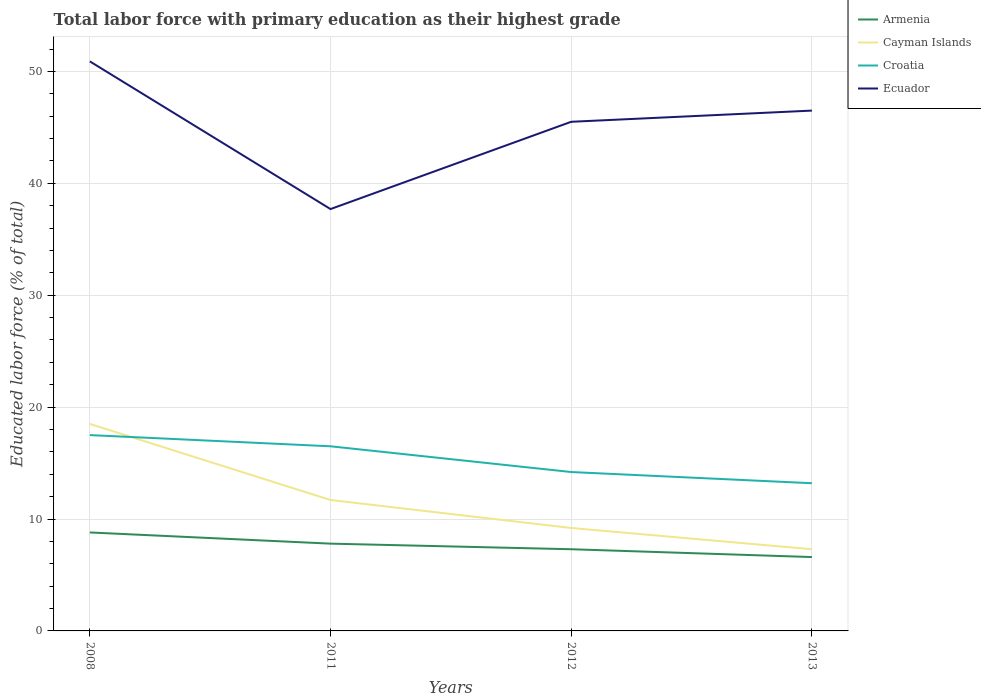Does the line corresponding to Cayman Islands intersect with the line corresponding to Croatia?
Ensure brevity in your answer.  Yes. Across all years, what is the maximum percentage of total labor force with primary education in Cayman Islands?
Offer a very short reply. 7.3. What is the total percentage of total labor force with primary education in Armenia in the graph?
Offer a very short reply. 1. What is the difference between the highest and the second highest percentage of total labor force with primary education in Ecuador?
Keep it short and to the point. 13.2. What is the difference between two consecutive major ticks on the Y-axis?
Keep it short and to the point. 10. Are the values on the major ticks of Y-axis written in scientific E-notation?
Offer a very short reply. No. Does the graph contain any zero values?
Provide a succinct answer. No. Does the graph contain grids?
Your answer should be compact. Yes. Where does the legend appear in the graph?
Provide a short and direct response. Top right. How are the legend labels stacked?
Provide a short and direct response. Vertical. What is the title of the graph?
Make the answer very short. Total labor force with primary education as their highest grade. Does "Bolivia" appear as one of the legend labels in the graph?
Offer a terse response. No. What is the label or title of the X-axis?
Ensure brevity in your answer.  Years. What is the label or title of the Y-axis?
Your answer should be very brief. Educated labor force (% of total). What is the Educated labor force (% of total) in Armenia in 2008?
Give a very brief answer. 8.8. What is the Educated labor force (% of total) in Ecuador in 2008?
Ensure brevity in your answer.  50.9. What is the Educated labor force (% of total) of Armenia in 2011?
Ensure brevity in your answer.  7.8. What is the Educated labor force (% of total) of Cayman Islands in 2011?
Keep it short and to the point. 11.7. What is the Educated labor force (% of total) in Ecuador in 2011?
Keep it short and to the point. 37.7. What is the Educated labor force (% of total) in Armenia in 2012?
Offer a very short reply. 7.3. What is the Educated labor force (% of total) in Cayman Islands in 2012?
Give a very brief answer. 9.2. What is the Educated labor force (% of total) of Croatia in 2012?
Provide a succinct answer. 14.2. What is the Educated labor force (% of total) of Ecuador in 2012?
Your answer should be compact. 45.5. What is the Educated labor force (% of total) in Armenia in 2013?
Make the answer very short. 6.6. What is the Educated labor force (% of total) in Cayman Islands in 2013?
Provide a succinct answer. 7.3. What is the Educated labor force (% of total) in Croatia in 2013?
Ensure brevity in your answer.  13.2. What is the Educated labor force (% of total) of Ecuador in 2013?
Keep it short and to the point. 46.5. Across all years, what is the maximum Educated labor force (% of total) in Armenia?
Provide a succinct answer. 8.8. Across all years, what is the maximum Educated labor force (% of total) in Cayman Islands?
Ensure brevity in your answer.  18.5. Across all years, what is the maximum Educated labor force (% of total) of Croatia?
Offer a terse response. 17.5. Across all years, what is the maximum Educated labor force (% of total) of Ecuador?
Provide a succinct answer. 50.9. Across all years, what is the minimum Educated labor force (% of total) in Armenia?
Offer a terse response. 6.6. Across all years, what is the minimum Educated labor force (% of total) of Cayman Islands?
Your response must be concise. 7.3. Across all years, what is the minimum Educated labor force (% of total) of Croatia?
Keep it short and to the point. 13.2. Across all years, what is the minimum Educated labor force (% of total) in Ecuador?
Provide a short and direct response. 37.7. What is the total Educated labor force (% of total) of Armenia in the graph?
Your answer should be compact. 30.5. What is the total Educated labor force (% of total) in Cayman Islands in the graph?
Give a very brief answer. 46.7. What is the total Educated labor force (% of total) in Croatia in the graph?
Give a very brief answer. 61.4. What is the total Educated labor force (% of total) in Ecuador in the graph?
Your response must be concise. 180.6. What is the difference between the Educated labor force (% of total) in Armenia in 2008 and that in 2011?
Keep it short and to the point. 1. What is the difference between the Educated labor force (% of total) in Croatia in 2008 and that in 2011?
Provide a short and direct response. 1. What is the difference between the Educated labor force (% of total) of Croatia in 2008 and that in 2012?
Your response must be concise. 3.3. What is the difference between the Educated labor force (% of total) in Armenia in 2008 and that in 2013?
Keep it short and to the point. 2.2. What is the difference between the Educated labor force (% of total) in Croatia in 2008 and that in 2013?
Your response must be concise. 4.3. What is the difference between the Educated labor force (% of total) of Armenia in 2011 and that in 2012?
Your answer should be compact. 0.5. What is the difference between the Educated labor force (% of total) of Ecuador in 2011 and that in 2012?
Give a very brief answer. -7.8. What is the difference between the Educated labor force (% of total) of Cayman Islands in 2011 and that in 2013?
Your response must be concise. 4.4. What is the difference between the Educated labor force (% of total) in Armenia in 2012 and that in 2013?
Provide a short and direct response. 0.7. What is the difference between the Educated labor force (% of total) of Croatia in 2012 and that in 2013?
Provide a short and direct response. 1. What is the difference between the Educated labor force (% of total) in Ecuador in 2012 and that in 2013?
Your response must be concise. -1. What is the difference between the Educated labor force (% of total) of Armenia in 2008 and the Educated labor force (% of total) of Ecuador in 2011?
Provide a succinct answer. -28.9. What is the difference between the Educated labor force (% of total) of Cayman Islands in 2008 and the Educated labor force (% of total) of Croatia in 2011?
Provide a succinct answer. 2. What is the difference between the Educated labor force (% of total) of Cayman Islands in 2008 and the Educated labor force (% of total) of Ecuador in 2011?
Provide a short and direct response. -19.2. What is the difference between the Educated labor force (% of total) in Croatia in 2008 and the Educated labor force (% of total) in Ecuador in 2011?
Your response must be concise. -20.2. What is the difference between the Educated labor force (% of total) of Armenia in 2008 and the Educated labor force (% of total) of Cayman Islands in 2012?
Provide a short and direct response. -0.4. What is the difference between the Educated labor force (% of total) of Armenia in 2008 and the Educated labor force (% of total) of Croatia in 2012?
Give a very brief answer. -5.4. What is the difference between the Educated labor force (% of total) in Armenia in 2008 and the Educated labor force (% of total) in Ecuador in 2012?
Your response must be concise. -36.7. What is the difference between the Educated labor force (% of total) of Cayman Islands in 2008 and the Educated labor force (% of total) of Croatia in 2012?
Your response must be concise. 4.3. What is the difference between the Educated labor force (% of total) of Cayman Islands in 2008 and the Educated labor force (% of total) of Ecuador in 2012?
Give a very brief answer. -27. What is the difference between the Educated labor force (% of total) in Croatia in 2008 and the Educated labor force (% of total) in Ecuador in 2012?
Offer a terse response. -28. What is the difference between the Educated labor force (% of total) of Armenia in 2008 and the Educated labor force (% of total) of Croatia in 2013?
Offer a terse response. -4.4. What is the difference between the Educated labor force (% of total) of Armenia in 2008 and the Educated labor force (% of total) of Ecuador in 2013?
Provide a succinct answer. -37.7. What is the difference between the Educated labor force (% of total) of Cayman Islands in 2008 and the Educated labor force (% of total) of Croatia in 2013?
Give a very brief answer. 5.3. What is the difference between the Educated labor force (% of total) in Croatia in 2008 and the Educated labor force (% of total) in Ecuador in 2013?
Offer a very short reply. -29. What is the difference between the Educated labor force (% of total) of Armenia in 2011 and the Educated labor force (% of total) of Cayman Islands in 2012?
Offer a terse response. -1.4. What is the difference between the Educated labor force (% of total) in Armenia in 2011 and the Educated labor force (% of total) in Croatia in 2012?
Keep it short and to the point. -6.4. What is the difference between the Educated labor force (% of total) of Armenia in 2011 and the Educated labor force (% of total) of Ecuador in 2012?
Provide a succinct answer. -37.7. What is the difference between the Educated labor force (% of total) in Cayman Islands in 2011 and the Educated labor force (% of total) in Croatia in 2012?
Give a very brief answer. -2.5. What is the difference between the Educated labor force (% of total) in Cayman Islands in 2011 and the Educated labor force (% of total) in Ecuador in 2012?
Ensure brevity in your answer.  -33.8. What is the difference between the Educated labor force (% of total) in Armenia in 2011 and the Educated labor force (% of total) in Ecuador in 2013?
Your answer should be compact. -38.7. What is the difference between the Educated labor force (% of total) in Cayman Islands in 2011 and the Educated labor force (% of total) in Croatia in 2013?
Offer a terse response. -1.5. What is the difference between the Educated labor force (% of total) of Cayman Islands in 2011 and the Educated labor force (% of total) of Ecuador in 2013?
Your answer should be compact. -34.8. What is the difference between the Educated labor force (% of total) in Croatia in 2011 and the Educated labor force (% of total) in Ecuador in 2013?
Provide a succinct answer. -30. What is the difference between the Educated labor force (% of total) of Armenia in 2012 and the Educated labor force (% of total) of Ecuador in 2013?
Offer a very short reply. -39.2. What is the difference between the Educated labor force (% of total) in Cayman Islands in 2012 and the Educated labor force (% of total) in Ecuador in 2013?
Your answer should be very brief. -37.3. What is the difference between the Educated labor force (% of total) in Croatia in 2012 and the Educated labor force (% of total) in Ecuador in 2013?
Provide a succinct answer. -32.3. What is the average Educated labor force (% of total) in Armenia per year?
Keep it short and to the point. 7.62. What is the average Educated labor force (% of total) in Cayman Islands per year?
Make the answer very short. 11.68. What is the average Educated labor force (% of total) in Croatia per year?
Your response must be concise. 15.35. What is the average Educated labor force (% of total) in Ecuador per year?
Offer a terse response. 45.15. In the year 2008, what is the difference between the Educated labor force (% of total) in Armenia and Educated labor force (% of total) in Cayman Islands?
Offer a very short reply. -9.7. In the year 2008, what is the difference between the Educated labor force (% of total) of Armenia and Educated labor force (% of total) of Croatia?
Make the answer very short. -8.7. In the year 2008, what is the difference between the Educated labor force (% of total) of Armenia and Educated labor force (% of total) of Ecuador?
Ensure brevity in your answer.  -42.1. In the year 2008, what is the difference between the Educated labor force (% of total) of Cayman Islands and Educated labor force (% of total) of Croatia?
Make the answer very short. 1. In the year 2008, what is the difference between the Educated labor force (% of total) of Cayman Islands and Educated labor force (% of total) of Ecuador?
Your answer should be compact. -32.4. In the year 2008, what is the difference between the Educated labor force (% of total) in Croatia and Educated labor force (% of total) in Ecuador?
Your response must be concise. -33.4. In the year 2011, what is the difference between the Educated labor force (% of total) in Armenia and Educated labor force (% of total) in Cayman Islands?
Ensure brevity in your answer.  -3.9. In the year 2011, what is the difference between the Educated labor force (% of total) of Armenia and Educated labor force (% of total) of Croatia?
Offer a very short reply. -8.7. In the year 2011, what is the difference between the Educated labor force (% of total) of Armenia and Educated labor force (% of total) of Ecuador?
Make the answer very short. -29.9. In the year 2011, what is the difference between the Educated labor force (% of total) of Cayman Islands and Educated labor force (% of total) of Croatia?
Provide a succinct answer. -4.8. In the year 2011, what is the difference between the Educated labor force (% of total) in Croatia and Educated labor force (% of total) in Ecuador?
Offer a terse response. -21.2. In the year 2012, what is the difference between the Educated labor force (% of total) in Armenia and Educated labor force (% of total) in Ecuador?
Keep it short and to the point. -38.2. In the year 2012, what is the difference between the Educated labor force (% of total) of Cayman Islands and Educated labor force (% of total) of Croatia?
Ensure brevity in your answer.  -5. In the year 2012, what is the difference between the Educated labor force (% of total) in Cayman Islands and Educated labor force (% of total) in Ecuador?
Offer a terse response. -36.3. In the year 2012, what is the difference between the Educated labor force (% of total) of Croatia and Educated labor force (% of total) of Ecuador?
Your answer should be very brief. -31.3. In the year 2013, what is the difference between the Educated labor force (% of total) in Armenia and Educated labor force (% of total) in Cayman Islands?
Give a very brief answer. -0.7. In the year 2013, what is the difference between the Educated labor force (% of total) in Armenia and Educated labor force (% of total) in Ecuador?
Keep it short and to the point. -39.9. In the year 2013, what is the difference between the Educated labor force (% of total) in Cayman Islands and Educated labor force (% of total) in Croatia?
Your answer should be compact. -5.9. In the year 2013, what is the difference between the Educated labor force (% of total) of Cayman Islands and Educated labor force (% of total) of Ecuador?
Your answer should be compact. -39.2. In the year 2013, what is the difference between the Educated labor force (% of total) in Croatia and Educated labor force (% of total) in Ecuador?
Your answer should be compact. -33.3. What is the ratio of the Educated labor force (% of total) of Armenia in 2008 to that in 2011?
Ensure brevity in your answer.  1.13. What is the ratio of the Educated labor force (% of total) in Cayman Islands in 2008 to that in 2011?
Offer a very short reply. 1.58. What is the ratio of the Educated labor force (% of total) in Croatia in 2008 to that in 2011?
Keep it short and to the point. 1.06. What is the ratio of the Educated labor force (% of total) in Ecuador in 2008 to that in 2011?
Make the answer very short. 1.35. What is the ratio of the Educated labor force (% of total) of Armenia in 2008 to that in 2012?
Your response must be concise. 1.21. What is the ratio of the Educated labor force (% of total) of Cayman Islands in 2008 to that in 2012?
Your answer should be very brief. 2.01. What is the ratio of the Educated labor force (% of total) in Croatia in 2008 to that in 2012?
Provide a short and direct response. 1.23. What is the ratio of the Educated labor force (% of total) of Ecuador in 2008 to that in 2012?
Ensure brevity in your answer.  1.12. What is the ratio of the Educated labor force (% of total) in Armenia in 2008 to that in 2013?
Provide a short and direct response. 1.33. What is the ratio of the Educated labor force (% of total) in Cayman Islands in 2008 to that in 2013?
Make the answer very short. 2.53. What is the ratio of the Educated labor force (% of total) of Croatia in 2008 to that in 2013?
Provide a succinct answer. 1.33. What is the ratio of the Educated labor force (% of total) in Ecuador in 2008 to that in 2013?
Give a very brief answer. 1.09. What is the ratio of the Educated labor force (% of total) in Armenia in 2011 to that in 2012?
Provide a short and direct response. 1.07. What is the ratio of the Educated labor force (% of total) of Cayman Islands in 2011 to that in 2012?
Your answer should be very brief. 1.27. What is the ratio of the Educated labor force (% of total) of Croatia in 2011 to that in 2012?
Provide a short and direct response. 1.16. What is the ratio of the Educated labor force (% of total) of Ecuador in 2011 to that in 2012?
Ensure brevity in your answer.  0.83. What is the ratio of the Educated labor force (% of total) in Armenia in 2011 to that in 2013?
Your response must be concise. 1.18. What is the ratio of the Educated labor force (% of total) of Cayman Islands in 2011 to that in 2013?
Your answer should be compact. 1.6. What is the ratio of the Educated labor force (% of total) of Croatia in 2011 to that in 2013?
Provide a succinct answer. 1.25. What is the ratio of the Educated labor force (% of total) of Ecuador in 2011 to that in 2013?
Your answer should be compact. 0.81. What is the ratio of the Educated labor force (% of total) of Armenia in 2012 to that in 2013?
Your answer should be very brief. 1.11. What is the ratio of the Educated labor force (% of total) in Cayman Islands in 2012 to that in 2013?
Offer a terse response. 1.26. What is the ratio of the Educated labor force (% of total) of Croatia in 2012 to that in 2013?
Offer a terse response. 1.08. What is the ratio of the Educated labor force (% of total) in Ecuador in 2012 to that in 2013?
Your response must be concise. 0.98. What is the difference between the highest and the second highest Educated labor force (% of total) in Cayman Islands?
Provide a short and direct response. 6.8. What is the difference between the highest and the lowest Educated labor force (% of total) of Armenia?
Your response must be concise. 2.2. What is the difference between the highest and the lowest Educated labor force (% of total) of Cayman Islands?
Offer a terse response. 11.2. What is the difference between the highest and the lowest Educated labor force (% of total) in Croatia?
Give a very brief answer. 4.3. 